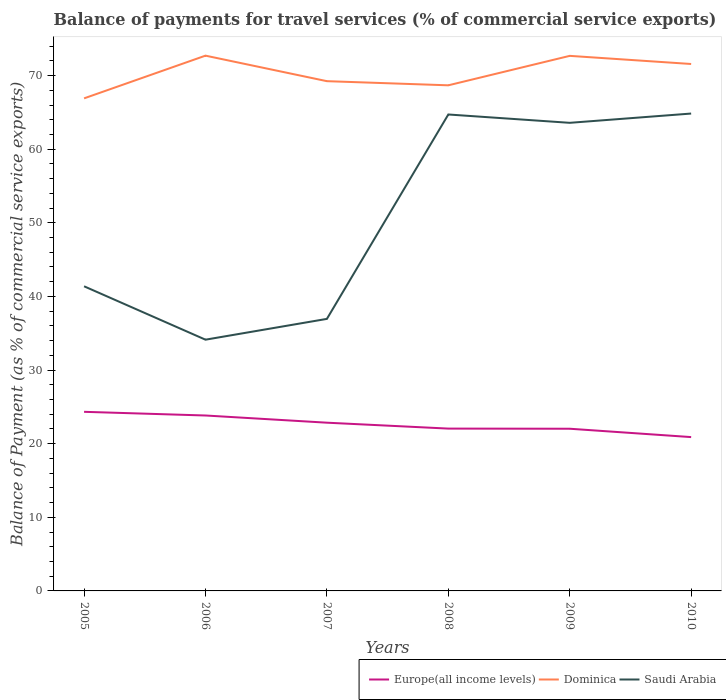How many different coloured lines are there?
Your answer should be very brief. 3. Does the line corresponding to Europe(all income levels) intersect with the line corresponding to Saudi Arabia?
Your response must be concise. No. Is the number of lines equal to the number of legend labels?
Ensure brevity in your answer.  Yes. Across all years, what is the maximum balance of payments for travel services in Europe(all income levels)?
Your answer should be very brief. 20.89. In which year was the balance of payments for travel services in Europe(all income levels) maximum?
Make the answer very short. 2010. What is the total balance of payments for travel services in Europe(all income levels) in the graph?
Your response must be concise. 0.82. What is the difference between the highest and the second highest balance of payments for travel services in Dominica?
Make the answer very short. 5.8. What is the difference between the highest and the lowest balance of payments for travel services in Saudi Arabia?
Keep it short and to the point. 3. How many lines are there?
Provide a succinct answer. 3. Are the values on the major ticks of Y-axis written in scientific E-notation?
Offer a very short reply. No. Does the graph contain grids?
Keep it short and to the point. No. Where does the legend appear in the graph?
Offer a terse response. Bottom right. How many legend labels are there?
Make the answer very short. 3. How are the legend labels stacked?
Ensure brevity in your answer.  Horizontal. What is the title of the graph?
Your answer should be compact. Balance of payments for travel services (% of commercial service exports). Does "Serbia" appear as one of the legend labels in the graph?
Provide a short and direct response. No. What is the label or title of the Y-axis?
Ensure brevity in your answer.  Balance of Payment (as % of commercial service exports). What is the Balance of Payment (as % of commercial service exports) in Europe(all income levels) in 2005?
Offer a terse response. 24.33. What is the Balance of Payment (as % of commercial service exports) of Dominica in 2005?
Provide a succinct answer. 66.91. What is the Balance of Payment (as % of commercial service exports) in Saudi Arabia in 2005?
Your response must be concise. 41.38. What is the Balance of Payment (as % of commercial service exports) of Europe(all income levels) in 2006?
Your answer should be compact. 23.83. What is the Balance of Payment (as % of commercial service exports) of Dominica in 2006?
Your answer should be very brief. 72.71. What is the Balance of Payment (as % of commercial service exports) in Saudi Arabia in 2006?
Your answer should be compact. 34.13. What is the Balance of Payment (as % of commercial service exports) in Europe(all income levels) in 2007?
Make the answer very short. 22.85. What is the Balance of Payment (as % of commercial service exports) of Dominica in 2007?
Provide a short and direct response. 69.24. What is the Balance of Payment (as % of commercial service exports) of Saudi Arabia in 2007?
Your answer should be very brief. 36.95. What is the Balance of Payment (as % of commercial service exports) of Europe(all income levels) in 2008?
Offer a very short reply. 22.05. What is the Balance of Payment (as % of commercial service exports) of Dominica in 2008?
Offer a very short reply. 68.68. What is the Balance of Payment (as % of commercial service exports) in Saudi Arabia in 2008?
Your answer should be very brief. 64.72. What is the Balance of Payment (as % of commercial service exports) in Europe(all income levels) in 2009?
Provide a succinct answer. 22.03. What is the Balance of Payment (as % of commercial service exports) of Dominica in 2009?
Make the answer very short. 72.68. What is the Balance of Payment (as % of commercial service exports) in Saudi Arabia in 2009?
Provide a short and direct response. 63.58. What is the Balance of Payment (as % of commercial service exports) in Europe(all income levels) in 2010?
Offer a terse response. 20.89. What is the Balance of Payment (as % of commercial service exports) of Dominica in 2010?
Keep it short and to the point. 71.57. What is the Balance of Payment (as % of commercial service exports) in Saudi Arabia in 2010?
Provide a short and direct response. 64.84. Across all years, what is the maximum Balance of Payment (as % of commercial service exports) of Europe(all income levels)?
Provide a short and direct response. 24.33. Across all years, what is the maximum Balance of Payment (as % of commercial service exports) in Dominica?
Keep it short and to the point. 72.71. Across all years, what is the maximum Balance of Payment (as % of commercial service exports) of Saudi Arabia?
Offer a very short reply. 64.84. Across all years, what is the minimum Balance of Payment (as % of commercial service exports) of Europe(all income levels)?
Provide a short and direct response. 20.89. Across all years, what is the minimum Balance of Payment (as % of commercial service exports) in Dominica?
Offer a terse response. 66.91. Across all years, what is the minimum Balance of Payment (as % of commercial service exports) of Saudi Arabia?
Make the answer very short. 34.13. What is the total Balance of Payment (as % of commercial service exports) in Europe(all income levels) in the graph?
Provide a short and direct response. 135.98. What is the total Balance of Payment (as % of commercial service exports) of Dominica in the graph?
Provide a short and direct response. 421.79. What is the total Balance of Payment (as % of commercial service exports) of Saudi Arabia in the graph?
Keep it short and to the point. 305.6. What is the difference between the Balance of Payment (as % of commercial service exports) of Europe(all income levels) in 2005 and that in 2006?
Offer a terse response. 0.5. What is the difference between the Balance of Payment (as % of commercial service exports) of Dominica in 2005 and that in 2006?
Your response must be concise. -5.8. What is the difference between the Balance of Payment (as % of commercial service exports) of Saudi Arabia in 2005 and that in 2006?
Ensure brevity in your answer.  7.25. What is the difference between the Balance of Payment (as % of commercial service exports) of Europe(all income levels) in 2005 and that in 2007?
Make the answer very short. 1.48. What is the difference between the Balance of Payment (as % of commercial service exports) of Dominica in 2005 and that in 2007?
Keep it short and to the point. -2.33. What is the difference between the Balance of Payment (as % of commercial service exports) in Saudi Arabia in 2005 and that in 2007?
Offer a terse response. 4.43. What is the difference between the Balance of Payment (as % of commercial service exports) of Europe(all income levels) in 2005 and that in 2008?
Your response must be concise. 2.28. What is the difference between the Balance of Payment (as % of commercial service exports) in Dominica in 2005 and that in 2008?
Keep it short and to the point. -1.77. What is the difference between the Balance of Payment (as % of commercial service exports) of Saudi Arabia in 2005 and that in 2008?
Offer a very short reply. -23.34. What is the difference between the Balance of Payment (as % of commercial service exports) in Europe(all income levels) in 2005 and that in 2009?
Keep it short and to the point. 2.3. What is the difference between the Balance of Payment (as % of commercial service exports) in Dominica in 2005 and that in 2009?
Your answer should be very brief. -5.77. What is the difference between the Balance of Payment (as % of commercial service exports) in Saudi Arabia in 2005 and that in 2009?
Provide a short and direct response. -22.21. What is the difference between the Balance of Payment (as % of commercial service exports) of Europe(all income levels) in 2005 and that in 2010?
Offer a very short reply. 3.44. What is the difference between the Balance of Payment (as % of commercial service exports) of Dominica in 2005 and that in 2010?
Make the answer very short. -4.67. What is the difference between the Balance of Payment (as % of commercial service exports) of Saudi Arabia in 2005 and that in 2010?
Offer a very short reply. -23.46. What is the difference between the Balance of Payment (as % of commercial service exports) in Europe(all income levels) in 2006 and that in 2007?
Your response must be concise. 0.98. What is the difference between the Balance of Payment (as % of commercial service exports) in Dominica in 2006 and that in 2007?
Offer a terse response. 3.47. What is the difference between the Balance of Payment (as % of commercial service exports) in Saudi Arabia in 2006 and that in 2007?
Ensure brevity in your answer.  -2.82. What is the difference between the Balance of Payment (as % of commercial service exports) in Europe(all income levels) in 2006 and that in 2008?
Your answer should be compact. 1.78. What is the difference between the Balance of Payment (as % of commercial service exports) of Dominica in 2006 and that in 2008?
Make the answer very short. 4.03. What is the difference between the Balance of Payment (as % of commercial service exports) in Saudi Arabia in 2006 and that in 2008?
Give a very brief answer. -30.59. What is the difference between the Balance of Payment (as % of commercial service exports) of Europe(all income levels) in 2006 and that in 2009?
Provide a succinct answer. 1.8. What is the difference between the Balance of Payment (as % of commercial service exports) of Dominica in 2006 and that in 2009?
Provide a succinct answer. 0.03. What is the difference between the Balance of Payment (as % of commercial service exports) of Saudi Arabia in 2006 and that in 2009?
Make the answer very short. -29.46. What is the difference between the Balance of Payment (as % of commercial service exports) in Europe(all income levels) in 2006 and that in 2010?
Provide a succinct answer. 2.93. What is the difference between the Balance of Payment (as % of commercial service exports) of Dominica in 2006 and that in 2010?
Your response must be concise. 1.13. What is the difference between the Balance of Payment (as % of commercial service exports) of Saudi Arabia in 2006 and that in 2010?
Your answer should be compact. -30.72. What is the difference between the Balance of Payment (as % of commercial service exports) of Europe(all income levels) in 2007 and that in 2008?
Make the answer very short. 0.8. What is the difference between the Balance of Payment (as % of commercial service exports) of Dominica in 2007 and that in 2008?
Provide a short and direct response. 0.56. What is the difference between the Balance of Payment (as % of commercial service exports) of Saudi Arabia in 2007 and that in 2008?
Your response must be concise. -27.76. What is the difference between the Balance of Payment (as % of commercial service exports) in Europe(all income levels) in 2007 and that in 2009?
Provide a succinct answer. 0.82. What is the difference between the Balance of Payment (as % of commercial service exports) in Dominica in 2007 and that in 2009?
Provide a short and direct response. -3.44. What is the difference between the Balance of Payment (as % of commercial service exports) in Saudi Arabia in 2007 and that in 2009?
Give a very brief answer. -26.63. What is the difference between the Balance of Payment (as % of commercial service exports) of Europe(all income levels) in 2007 and that in 2010?
Provide a short and direct response. 1.96. What is the difference between the Balance of Payment (as % of commercial service exports) of Dominica in 2007 and that in 2010?
Your response must be concise. -2.33. What is the difference between the Balance of Payment (as % of commercial service exports) in Saudi Arabia in 2007 and that in 2010?
Offer a terse response. -27.89. What is the difference between the Balance of Payment (as % of commercial service exports) in Europe(all income levels) in 2008 and that in 2009?
Your answer should be compact. 0.02. What is the difference between the Balance of Payment (as % of commercial service exports) in Dominica in 2008 and that in 2009?
Ensure brevity in your answer.  -4. What is the difference between the Balance of Payment (as % of commercial service exports) in Saudi Arabia in 2008 and that in 2009?
Give a very brief answer. 1.13. What is the difference between the Balance of Payment (as % of commercial service exports) in Europe(all income levels) in 2008 and that in 2010?
Ensure brevity in your answer.  1.16. What is the difference between the Balance of Payment (as % of commercial service exports) in Dominica in 2008 and that in 2010?
Your answer should be very brief. -2.9. What is the difference between the Balance of Payment (as % of commercial service exports) of Saudi Arabia in 2008 and that in 2010?
Your response must be concise. -0.13. What is the difference between the Balance of Payment (as % of commercial service exports) of Europe(all income levels) in 2009 and that in 2010?
Give a very brief answer. 1.14. What is the difference between the Balance of Payment (as % of commercial service exports) in Dominica in 2009 and that in 2010?
Offer a terse response. 1.1. What is the difference between the Balance of Payment (as % of commercial service exports) in Saudi Arabia in 2009 and that in 2010?
Give a very brief answer. -1.26. What is the difference between the Balance of Payment (as % of commercial service exports) in Europe(all income levels) in 2005 and the Balance of Payment (as % of commercial service exports) in Dominica in 2006?
Provide a short and direct response. -48.38. What is the difference between the Balance of Payment (as % of commercial service exports) of Europe(all income levels) in 2005 and the Balance of Payment (as % of commercial service exports) of Saudi Arabia in 2006?
Your answer should be compact. -9.8. What is the difference between the Balance of Payment (as % of commercial service exports) in Dominica in 2005 and the Balance of Payment (as % of commercial service exports) in Saudi Arabia in 2006?
Provide a succinct answer. 32.78. What is the difference between the Balance of Payment (as % of commercial service exports) in Europe(all income levels) in 2005 and the Balance of Payment (as % of commercial service exports) in Dominica in 2007?
Ensure brevity in your answer.  -44.91. What is the difference between the Balance of Payment (as % of commercial service exports) in Europe(all income levels) in 2005 and the Balance of Payment (as % of commercial service exports) in Saudi Arabia in 2007?
Keep it short and to the point. -12.62. What is the difference between the Balance of Payment (as % of commercial service exports) of Dominica in 2005 and the Balance of Payment (as % of commercial service exports) of Saudi Arabia in 2007?
Offer a terse response. 29.95. What is the difference between the Balance of Payment (as % of commercial service exports) of Europe(all income levels) in 2005 and the Balance of Payment (as % of commercial service exports) of Dominica in 2008?
Offer a terse response. -44.35. What is the difference between the Balance of Payment (as % of commercial service exports) of Europe(all income levels) in 2005 and the Balance of Payment (as % of commercial service exports) of Saudi Arabia in 2008?
Ensure brevity in your answer.  -40.39. What is the difference between the Balance of Payment (as % of commercial service exports) in Dominica in 2005 and the Balance of Payment (as % of commercial service exports) in Saudi Arabia in 2008?
Give a very brief answer. 2.19. What is the difference between the Balance of Payment (as % of commercial service exports) of Europe(all income levels) in 2005 and the Balance of Payment (as % of commercial service exports) of Dominica in 2009?
Offer a very short reply. -48.35. What is the difference between the Balance of Payment (as % of commercial service exports) in Europe(all income levels) in 2005 and the Balance of Payment (as % of commercial service exports) in Saudi Arabia in 2009?
Give a very brief answer. -39.25. What is the difference between the Balance of Payment (as % of commercial service exports) of Dominica in 2005 and the Balance of Payment (as % of commercial service exports) of Saudi Arabia in 2009?
Offer a terse response. 3.32. What is the difference between the Balance of Payment (as % of commercial service exports) in Europe(all income levels) in 2005 and the Balance of Payment (as % of commercial service exports) in Dominica in 2010?
Make the answer very short. -47.24. What is the difference between the Balance of Payment (as % of commercial service exports) of Europe(all income levels) in 2005 and the Balance of Payment (as % of commercial service exports) of Saudi Arabia in 2010?
Provide a short and direct response. -40.51. What is the difference between the Balance of Payment (as % of commercial service exports) of Dominica in 2005 and the Balance of Payment (as % of commercial service exports) of Saudi Arabia in 2010?
Your response must be concise. 2.06. What is the difference between the Balance of Payment (as % of commercial service exports) in Europe(all income levels) in 2006 and the Balance of Payment (as % of commercial service exports) in Dominica in 2007?
Ensure brevity in your answer.  -45.41. What is the difference between the Balance of Payment (as % of commercial service exports) of Europe(all income levels) in 2006 and the Balance of Payment (as % of commercial service exports) of Saudi Arabia in 2007?
Provide a succinct answer. -13.12. What is the difference between the Balance of Payment (as % of commercial service exports) in Dominica in 2006 and the Balance of Payment (as % of commercial service exports) in Saudi Arabia in 2007?
Provide a succinct answer. 35.76. What is the difference between the Balance of Payment (as % of commercial service exports) in Europe(all income levels) in 2006 and the Balance of Payment (as % of commercial service exports) in Dominica in 2008?
Your answer should be compact. -44.85. What is the difference between the Balance of Payment (as % of commercial service exports) in Europe(all income levels) in 2006 and the Balance of Payment (as % of commercial service exports) in Saudi Arabia in 2008?
Your response must be concise. -40.89. What is the difference between the Balance of Payment (as % of commercial service exports) in Dominica in 2006 and the Balance of Payment (as % of commercial service exports) in Saudi Arabia in 2008?
Give a very brief answer. 7.99. What is the difference between the Balance of Payment (as % of commercial service exports) of Europe(all income levels) in 2006 and the Balance of Payment (as % of commercial service exports) of Dominica in 2009?
Offer a very short reply. -48.85. What is the difference between the Balance of Payment (as % of commercial service exports) in Europe(all income levels) in 2006 and the Balance of Payment (as % of commercial service exports) in Saudi Arabia in 2009?
Make the answer very short. -39.75. What is the difference between the Balance of Payment (as % of commercial service exports) of Dominica in 2006 and the Balance of Payment (as % of commercial service exports) of Saudi Arabia in 2009?
Make the answer very short. 9.12. What is the difference between the Balance of Payment (as % of commercial service exports) of Europe(all income levels) in 2006 and the Balance of Payment (as % of commercial service exports) of Dominica in 2010?
Your answer should be very brief. -47.75. What is the difference between the Balance of Payment (as % of commercial service exports) in Europe(all income levels) in 2006 and the Balance of Payment (as % of commercial service exports) in Saudi Arabia in 2010?
Offer a terse response. -41.01. What is the difference between the Balance of Payment (as % of commercial service exports) in Dominica in 2006 and the Balance of Payment (as % of commercial service exports) in Saudi Arabia in 2010?
Your answer should be compact. 7.87. What is the difference between the Balance of Payment (as % of commercial service exports) of Europe(all income levels) in 2007 and the Balance of Payment (as % of commercial service exports) of Dominica in 2008?
Offer a very short reply. -45.83. What is the difference between the Balance of Payment (as % of commercial service exports) of Europe(all income levels) in 2007 and the Balance of Payment (as % of commercial service exports) of Saudi Arabia in 2008?
Your response must be concise. -41.86. What is the difference between the Balance of Payment (as % of commercial service exports) of Dominica in 2007 and the Balance of Payment (as % of commercial service exports) of Saudi Arabia in 2008?
Offer a very short reply. 4.53. What is the difference between the Balance of Payment (as % of commercial service exports) of Europe(all income levels) in 2007 and the Balance of Payment (as % of commercial service exports) of Dominica in 2009?
Provide a short and direct response. -49.83. What is the difference between the Balance of Payment (as % of commercial service exports) of Europe(all income levels) in 2007 and the Balance of Payment (as % of commercial service exports) of Saudi Arabia in 2009?
Your answer should be compact. -40.73. What is the difference between the Balance of Payment (as % of commercial service exports) in Dominica in 2007 and the Balance of Payment (as % of commercial service exports) in Saudi Arabia in 2009?
Keep it short and to the point. 5.66. What is the difference between the Balance of Payment (as % of commercial service exports) in Europe(all income levels) in 2007 and the Balance of Payment (as % of commercial service exports) in Dominica in 2010?
Make the answer very short. -48.72. What is the difference between the Balance of Payment (as % of commercial service exports) in Europe(all income levels) in 2007 and the Balance of Payment (as % of commercial service exports) in Saudi Arabia in 2010?
Ensure brevity in your answer.  -41.99. What is the difference between the Balance of Payment (as % of commercial service exports) of Dominica in 2007 and the Balance of Payment (as % of commercial service exports) of Saudi Arabia in 2010?
Make the answer very short. 4.4. What is the difference between the Balance of Payment (as % of commercial service exports) in Europe(all income levels) in 2008 and the Balance of Payment (as % of commercial service exports) in Dominica in 2009?
Offer a terse response. -50.63. What is the difference between the Balance of Payment (as % of commercial service exports) of Europe(all income levels) in 2008 and the Balance of Payment (as % of commercial service exports) of Saudi Arabia in 2009?
Keep it short and to the point. -41.53. What is the difference between the Balance of Payment (as % of commercial service exports) of Dominica in 2008 and the Balance of Payment (as % of commercial service exports) of Saudi Arabia in 2009?
Your answer should be very brief. 5.09. What is the difference between the Balance of Payment (as % of commercial service exports) in Europe(all income levels) in 2008 and the Balance of Payment (as % of commercial service exports) in Dominica in 2010?
Offer a very short reply. -49.52. What is the difference between the Balance of Payment (as % of commercial service exports) in Europe(all income levels) in 2008 and the Balance of Payment (as % of commercial service exports) in Saudi Arabia in 2010?
Offer a very short reply. -42.79. What is the difference between the Balance of Payment (as % of commercial service exports) in Dominica in 2008 and the Balance of Payment (as % of commercial service exports) in Saudi Arabia in 2010?
Make the answer very short. 3.84. What is the difference between the Balance of Payment (as % of commercial service exports) of Europe(all income levels) in 2009 and the Balance of Payment (as % of commercial service exports) of Dominica in 2010?
Offer a very short reply. -49.54. What is the difference between the Balance of Payment (as % of commercial service exports) in Europe(all income levels) in 2009 and the Balance of Payment (as % of commercial service exports) in Saudi Arabia in 2010?
Keep it short and to the point. -42.81. What is the difference between the Balance of Payment (as % of commercial service exports) in Dominica in 2009 and the Balance of Payment (as % of commercial service exports) in Saudi Arabia in 2010?
Keep it short and to the point. 7.84. What is the average Balance of Payment (as % of commercial service exports) in Europe(all income levels) per year?
Provide a short and direct response. 22.66. What is the average Balance of Payment (as % of commercial service exports) of Dominica per year?
Offer a terse response. 70.3. What is the average Balance of Payment (as % of commercial service exports) of Saudi Arabia per year?
Your answer should be compact. 50.93. In the year 2005, what is the difference between the Balance of Payment (as % of commercial service exports) in Europe(all income levels) and Balance of Payment (as % of commercial service exports) in Dominica?
Your answer should be compact. -42.58. In the year 2005, what is the difference between the Balance of Payment (as % of commercial service exports) of Europe(all income levels) and Balance of Payment (as % of commercial service exports) of Saudi Arabia?
Your answer should be very brief. -17.05. In the year 2005, what is the difference between the Balance of Payment (as % of commercial service exports) of Dominica and Balance of Payment (as % of commercial service exports) of Saudi Arabia?
Your answer should be very brief. 25.53. In the year 2006, what is the difference between the Balance of Payment (as % of commercial service exports) of Europe(all income levels) and Balance of Payment (as % of commercial service exports) of Dominica?
Offer a very short reply. -48.88. In the year 2006, what is the difference between the Balance of Payment (as % of commercial service exports) of Europe(all income levels) and Balance of Payment (as % of commercial service exports) of Saudi Arabia?
Provide a short and direct response. -10.3. In the year 2006, what is the difference between the Balance of Payment (as % of commercial service exports) in Dominica and Balance of Payment (as % of commercial service exports) in Saudi Arabia?
Offer a terse response. 38.58. In the year 2007, what is the difference between the Balance of Payment (as % of commercial service exports) of Europe(all income levels) and Balance of Payment (as % of commercial service exports) of Dominica?
Provide a succinct answer. -46.39. In the year 2007, what is the difference between the Balance of Payment (as % of commercial service exports) of Europe(all income levels) and Balance of Payment (as % of commercial service exports) of Saudi Arabia?
Provide a short and direct response. -14.1. In the year 2007, what is the difference between the Balance of Payment (as % of commercial service exports) of Dominica and Balance of Payment (as % of commercial service exports) of Saudi Arabia?
Your answer should be compact. 32.29. In the year 2008, what is the difference between the Balance of Payment (as % of commercial service exports) in Europe(all income levels) and Balance of Payment (as % of commercial service exports) in Dominica?
Give a very brief answer. -46.63. In the year 2008, what is the difference between the Balance of Payment (as % of commercial service exports) of Europe(all income levels) and Balance of Payment (as % of commercial service exports) of Saudi Arabia?
Offer a very short reply. -42.67. In the year 2008, what is the difference between the Balance of Payment (as % of commercial service exports) of Dominica and Balance of Payment (as % of commercial service exports) of Saudi Arabia?
Your answer should be very brief. 3.96. In the year 2009, what is the difference between the Balance of Payment (as % of commercial service exports) of Europe(all income levels) and Balance of Payment (as % of commercial service exports) of Dominica?
Offer a terse response. -50.65. In the year 2009, what is the difference between the Balance of Payment (as % of commercial service exports) in Europe(all income levels) and Balance of Payment (as % of commercial service exports) in Saudi Arabia?
Ensure brevity in your answer.  -41.55. In the year 2009, what is the difference between the Balance of Payment (as % of commercial service exports) in Dominica and Balance of Payment (as % of commercial service exports) in Saudi Arabia?
Your answer should be compact. 9.1. In the year 2010, what is the difference between the Balance of Payment (as % of commercial service exports) of Europe(all income levels) and Balance of Payment (as % of commercial service exports) of Dominica?
Provide a succinct answer. -50.68. In the year 2010, what is the difference between the Balance of Payment (as % of commercial service exports) of Europe(all income levels) and Balance of Payment (as % of commercial service exports) of Saudi Arabia?
Keep it short and to the point. -43.95. In the year 2010, what is the difference between the Balance of Payment (as % of commercial service exports) in Dominica and Balance of Payment (as % of commercial service exports) in Saudi Arabia?
Your answer should be very brief. 6.73. What is the ratio of the Balance of Payment (as % of commercial service exports) of Europe(all income levels) in 2005 to that in 2006?
Give a very brief answer. 1.02. What is the ratio of the Balance of Payment (as % of commercial service exports) in Dominica in 2005 to that in 2006?
Provide a succinct answer. 0.92. What is the ratio of the Balance of Payment (as % of commercial service exports) of Saudi Arabia in 2005 to that in 2006?
Give a very brief answer. 1.21. What is the ratio of the Balance of Payment (as % of commercial service exports) in Europe(all income levels) in 2005 to that in 2007?
Your answer should be compact. 1.06. What is the ratio of the Balance of Payment (as % of commercial service exports) of Dominica in 2005 to that in 2007?
Offer a very short reply. 0.97. What is the ratio of the Balance of Payment (as % of commercial service exports) of Saudi Arabia in 2005 to that in 2007?
Your response must be concise. 1.12. What is the ratio of the Balance of Payment (as % of commercial service exports) in Europe(all income levels) in 2005 to that in 2008?
Offer a very short reply. 1.1. What is the ratio of the Balance of Payment (as % of commercial service exports) of Dominica in 2005 to that in 2008?
Provide a succinct answer. 0.97. What is the ratio of the Balance of Payment (as % of commercial service exports) in Saudi Arabia in 2005 to that in 2008?
Make the answer very short. 0.64. What is the ratio of the Balance of Payment (as % of commercial service exports) of Europe(all income levels) in 2005 to that in 2009?
Make the answer very short. 1.1. What is the ratio of the Balance of Payment (as % of commercial service exports) in Dominica in 2005 to that in 2009?
Make the answer very short. 0.92. What is the ratio of the Balance of Payment (as % of commercial service exports) of Saudi Arabia in 2005 to that in 2009?
Give a very brief answer. 0.65. What is the ratio of the Balance of Payment (as % of commercial service exports) of Europe(all income levels) in 2005 to that in 2010?
Offer a very short reply. 1.16. What is the ratio of the Balance of Payment (as % of commercial service exports) of Dominica in 2005 to that in 2010?
Ensure brevity in your answer.  0.93. What is the ratio of the Balance of Payment (as % of commercial service exports) in Saudi Arabia in 2005 to that in 2010?
Offer a very short reply. 0.64. What is the ratio of the Balance of Payment (as % of commercial service exports) in Europe(all income levels) in 2006 to that in 2007?
Offer a very short reply. 1.04. What is the ratio of the Balance of Payment (as % of commercial service exports) of Dominica in 2006 to that in 2007?
Provide a short and direct response. 1.05. What is the ratio of the Balance of Payment (as % of commercial service exports) of Saudi Arabia in 2006 to that in 2007?
Offer a terse response. 0.92. What is the ratio of the Balance of Payment (as % of commercial service exports) in Europe(all income levels) in 2006 to that in 2008?
Ensure brevity in your answer.  1.08. What is the ratio of the Balance of Payment (as % of commercial service exports) in Dominica in 2006 to that in 2008?
Give a very brief answer. 1.06. What is the ratio of the Balance of Payment (as % of commercial service exports) in Saudi Arabia in 2006 to that in 2008?
Your answer should be compact. 0.53. What is the ratio of the Balance of Payment (as % of commercial service exports) of Europe(all income levels) in 2006 to that in 2009?
Provide a succinct answer. 1.08. What is the ratio of the Balance of Payment (as % of commercial service exports) of Saudi Arabia in 2006 to that in 2009?
Ensure brevity in your answer.  0.54. What is the ratio of the Balance of Payment (as % of commercial service exports) of Europe(all income levels) in 2006 to that in 2010?
Make the answer very short. 1.14. What is the ratio of the Balance of Payment (as % of commercial service exports) of Dominica in 2006 to that in 2010?
Keep it short and to the point. 1.02. What is the ratio of the Balance of Payment (as % of commercial service exports) in Saudi Arabia in 2006 to that in 2010?
Make the answer very short. 0.53. What is the ratio of the Balance of Payment (as % of commercial service exports) of Europe(all income levels) in 2007 to that in 2008?
Your answer should be very brief. 1.04. What is the ratio of the Balance of Payment (as % of commercial service exports) in Dominica in 2007 to that in 2008?
Your answer should be very brief. 1.01. What is the ratio of the Balance of Payment (as % of commercial service exports) of Saudi Arabia in 2007 to that in 2008?
Offer a terse response. 0.57. What is the ratio of the Balance of Payment (as % of commercial service exports) in Europe(all income levels) in 2007 to that in 2009?
Your answer should be very brief. 1.04. What is the ratio of the Balance of Payment (as % of commercial service exports) in Dominica in 2007 to that in 2009?
Offer a terse response. 0.95. What is the ratio of the Balance of Payment (as % of commercial service exports) in Saudi Arabia in 2007 to that in 2009?
Offer a very short reply. 0.58. What is the ratio of the Balance of Payment (as % of commercial service exports) of Europe(all income levels) in 2007 to that in 2010?
Make the answer very short. 1.09. What is the ratio of the Balance of Payment (as % of commercial service exports) in Dominica in 2007 to that in 2010?
Your answer should be very brief. 0.97. What is the ratio of the Balance of Payment (as % of commercial service exports) of Saudi Arabia in 2007 to that in 2010?
Offer a terse response. 0.57. What is the ratio of the Balance of Payment (as % of commercial service exports) of Dominica in 2008 to that in 2009?
Provide a short and direct response. 0.94. What is the ratio of the Balance of Payment (as % of commercial service exports) of Saudi Arabia in 2008 to that in 2009?
Your answer should be very brief. 1.02. What is the ratio of the Balance of Payment (as % of commercial service exports) in Europe(all income levels) in 2008 to that in 2010?
Ensure brevity in your answer.  1.06. What is the ratio of the Balance of Payment (as % of commercial service exports) of Dominica in 2008 to that in 2010?
Keep it short and to the point. 0.96. What is the ratio of the Balance of Payment (as % of commercial service exports) of Europe(all income levels) in 2009 to that in 2010?
Give a very brief answer. 1.05. What is the ratio of the Balance of Payment (as % of commercial service exports) of Dominica in 2009 to that in 2010?
Offer a terse response. 1.02. What is the ratio of the Balance of Payment (as % of commercial service exports) in Saudi Arabia in 2009 to that in 2010?
Provide a short and direct response. 0.98. What is the difference between the highest and the second highest Balance of Payment (as % of commercial service exports) of Europe(all income levels)?
Your response must be concise. 0.5. What is the difference between the highest and the second highest Balance of Payment (as % of commercial service exports) in Dominica?
Give a very brief answer. 0.03. What is the difference between the highest and the second highest Balance of Payment (as % of commercial service exports) in Saudi Arabia?
Your answer should be compact. 0.13. What is the difference between the highest and the lowest Balance of Payment (as % of commercial service exports) of Europe(all income levels)?
Your answer should be compact. 3.44. What is the difference between the highest and the lowest Balance of Payment (as % of commercial service exports) in Dominica?
Ensure brevity in your answer.  5.8. What is the difference between the highest and the lowest Balance of Payment (as % of commercial service exports) of Saudi Arabia?
Ensure brevity in your answer.  30.72. 